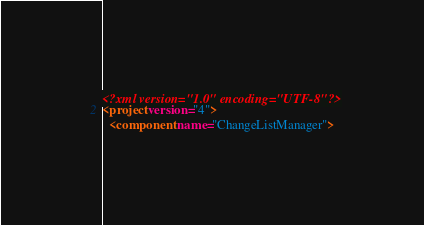<code> <loc_0><loc_0><loc_500><loc_500><_XML_><?xml version="1.0" encoding="UTF-8"?>
<project version="4">
  <component name="ChangeListManager"></code> 